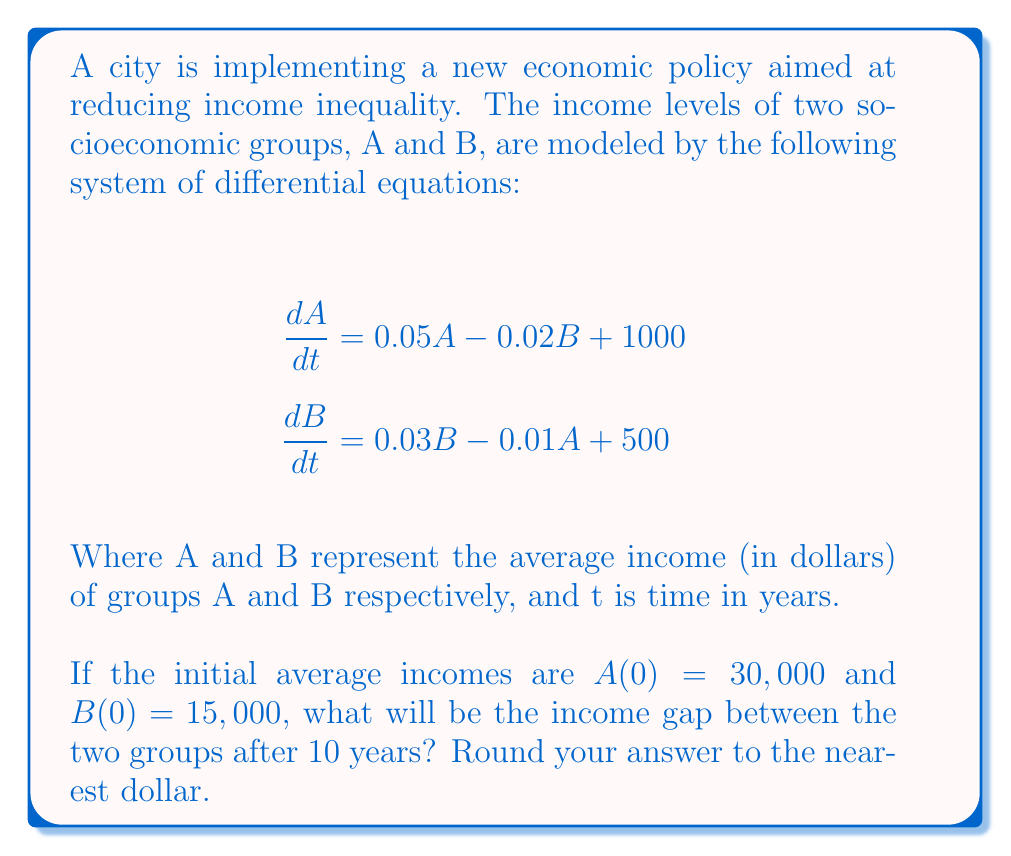Show me your answer to this math problem. To solve this problem, we need to follow these steps:

1) First, we need to solve the system of differential equations. This is a complex task, so we'll use a numerical method like Euler's method or Runge-Kutta. For simplicity, let's use Euler's method with a step size of 1 year.

2) Euler's method for a system of differential equations is given by:
   $$A_{n+1} = A_n + h \cdot f(A_n, B_n)$$
   $$B_{n+1} = B_n + h \cdot g(A_n, B_n)$$
   Where h is the step size (1 year in our case), and f and g are the right-hand sides of our differential equations.

3) We'll create a loop to iterate through 10 steps:

   For n = 0 to 9:
   $$A_{n+1} = A_n + 1 \cdot (0.05A_n - 0.02B_n + 1000)$$
   $$B_{n+1} = B_n + 1 \cdot (0.03B_n - 0.01A_n + 500)$$

4) Starting with $A_0 = 30000$ and $B_0 = 15000$, we compute:

   Year 1: $A_1 = 32300$, $B_1 = 15650$
   Year 2: $A_2 = 34783$, $B_2 = 16354$
   ...
   Year 10: $A_{10} = 55374$, $B_{10} = 22688$

5) The income gap after 10 years is the difference between these values:
   $55374 - 22688 = 32686$

Therefore, the income gap between the two groups after 10 years will be $32,686.
Answer: $32,686 